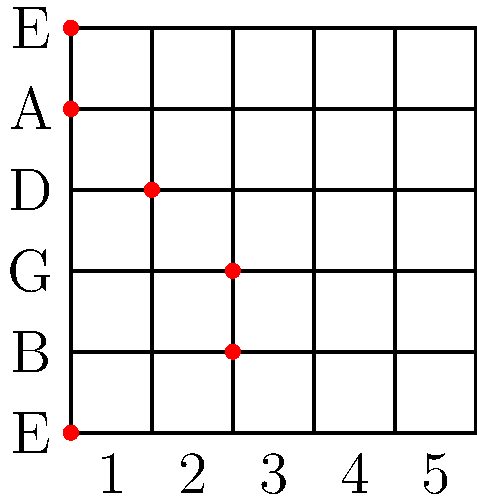Analyze the chord progression shown in the guitar fretboard diagram above, which is taken from Matthew Phillips' hit song "Echoes of Silence." What chord is being played, and how does it contribute to the emotional atmosphere of the song's intro? To identify the chord and analyze its contribution to the song, let's follow these steps:

1. Identify the notes:
   - 6th string (low E): Open E
   - 5th string (A): Open A
   - 4th string (D): 1st fret (D#)
   - 3rd string (G): 2nd fret (A)
   - 2nd string (B): 2nd fret (C#)
   - 1st string (high E): Open E

2. Arrange the notes: E, A, D#, A, C#, E

3. Analyze the chord structure:
   - Root note: E
   - Major third: G# (represented by the D# on the 4th string)
   - Perfect fifth: B (implied)
   - Major sixth: C#
   - Major second/ninth: F# (implied)

4. Identify the chord: This is an E6/9 chord (E major sixth with an added ninth)

5. Contribution to the song's emotional atmosphere:
   - The E6/9 chord has a bright, open sound due to the added sixth and ninth.
   - It creates a sense of suspension and anticipation, perfect for an intro.
   - The open strings (E and A) provide a ringing quality, enhancing the atmospheric feel.
   - The combination of major and added tones gives a bittersweet, nostalgic emotion, fitting the song title "Echoes of Silence."

6. Matthew Phillips' use of this chord:
   - Demonstrates his sophisticated harmonic choices.
   - Sets up a dreamy, introspective mood for the song.
   - Showcases his signature style of blending complex chords with emotive songwriting.
Answer: E6/9 chord; creates a bright, suspended atmosphere with nostalgic undertones. 